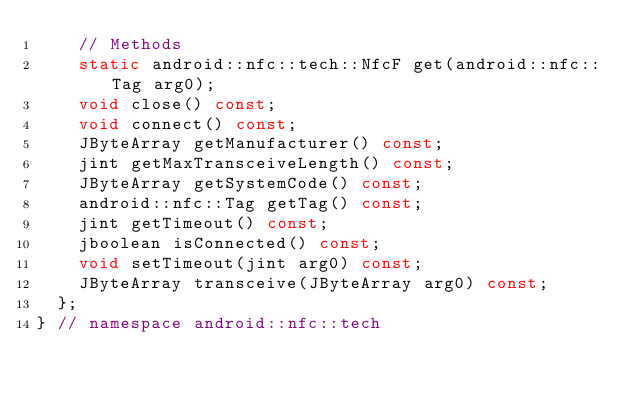<code> <loc_0><loc_0><loc_500><loc_500><_C++_>		// Methods
		static android::nfc::tech::NfcF get(android::nfc::Tag arg0);
		void close() const;
		void connect() const;
		JByteArray getManufacturer() const;
		jint getMaxTransceiveLength() const;
		JByteArray getSystemCode() const;
		android::nfc::Tag getTag() const;
		jint getTimeout() const;
		jboolean isConnected() const;
		void setTimeout(jint arg0) const;
		JByteArray transceive(JByteArray arg0) const;
	};
} // namespace android::nfc::tech

</code> 